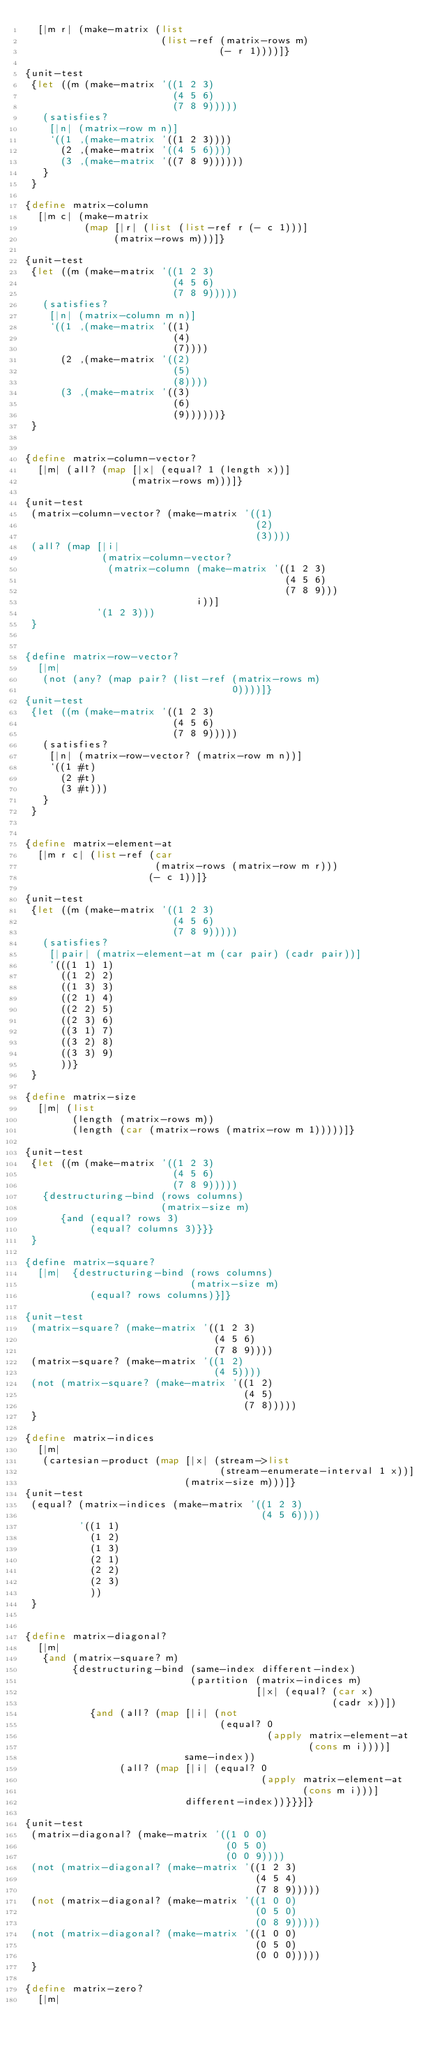Convert code to text. <code><loc_0><loc_0><loc_500><loc_500><_Scheme_>  [|m r| (make-matrix (list
                       (list-ref (matrix-rows m)
                                 (- r 1))))]}

{unit-test
 {let ((m (make-matrix '((1 2 3)
                         (4 5 6)
                         (7 8 9)))))
   (satisfies?
    [|n| (matrix-row m n)]
    `((1 ,(make-matrix '((1 2 3))))
      (2 ,(make-matrix '((4 5 6))))
      (3 ,(make-matrix '((7 8 9))))))
   }
 }

{define matrix-column
  [|m c| (make-matrix
          (map [|r| (list (list-ref r (- c 1)))]
               (matrix-rows m)))]}

{unit-test
 {let ((m (make-matrix '((1 2 3)
                         (4 5 6)
                         (7 8 9)))))
   (satisfies?
    [|n| (matrix-column m n)]
    `((1 ,(make-matrix '((1)
                         (4)
                         (7))))
      (2 ,(make-matrix '((2)
                         (5)
                         (8))))
      (3 ,(make-matrix '((3)
                         (6)
                         (9))))))}
 }


{define matrix-column-vector?
  [|m| (all? (map [|x| (equal? 1 (length x))]
                  (matrix-rows m)))]}

{unit-test
 (matrix-column-vector? (make-matrix '((1)
                                       (2)
                                       (3))))
 (all? (map [|i|
             (matrix-column-vector?
              (matrix-column (make-matrix '((1 2 3)
                                            (4 5 6)
                                            (7 8 9)))
                             i))]
            '(1 2 3)))
 }


{define matrix-row-vector?
  [|m|
   (not (any? (map pair? (list-ref (matrix-rows m)
                                   0))))]}
{unit-test
 {let ((m (make-matrix '((1 2 3)
                         (4 5 6)
                         (7 8 9)))))
   (satisfies?
    [|n| (matrix-row-vector? (matrix-row m n))]
    `((1 #t)
      (2 #t)
      (3 #t)))
   }
 }


{define matrix-element-at
  [|m r c| (list-ref (car
                      (matrix-rows (matrix-row m r)))
                     (- c 1))]}

{unit-test
 {let ((m (make-matrix '((1 2 3)
                         (4 5 6)
                         (7 8 9)))))
   (satisfies?
    [|pair| (matrix-element-at m (car pair) (cadr pair))]
    '(((1 1) 1)
      ((1 2) 2)
      ((1 3) 3)
      ((2 1) 4)
      ((2 2) 5)
      ((2 3) 6)
      ((3 1) 7)
      ((3 2) 8)
      ((3 3) 9)
      ))}
 }

{define matrix-size
  [|m| (list
        (length (matrix-rows m))
        (length (car (matrix-rows (matrix-row m 1)))))]}

{unit-test
 {let ((m (make-matrix '((1 2 3)
                         (4 5 6)
                         (7 8 9)))))
   {destructuring-bind (rows columns)
                       (matrix-size m)
      {and (equal? rows 3)
           (equal? columns 3)}}}
 }

{define matrix-square?
  [|m|  {destructuring-bind (rows columns)
                            (matrix-size m)
           (equal? rows columns)}]}

{unit-test
 (matrix-square? (make-matrix '((1 2 3)
                                (4 5 6)
                                (7 8 9))))
 (matrix-square? (make-matrix '((1 2)
                                (4 5))))
 (not (matrix-square? (make-matrix '((1 2)
                                     (4 5)
                                     (7 8)))))
 }

{define matrix-indices
  [|m|
   (cartesian-product (map [|x| (stream->list
                                 (stream-enumerate-interval 1 x))]
                           (matrix-size m)))]}
{unit-test
 (equal? (matrix-indices (make-matrix '((1 2 3)
                                        (4 5 6))))
         '((1 1)
           (1 2)
           (1 3)
           (2 1)
           (2 2)
           (2 3)
           ))
 }


{define matrix-diagonal?
  [|m|
   {and (matrix-square? m)
        {destructuring-bind (same-index different-index)
                            (partition (matrix-indices m)
                                       [|x| (equal? (car x)
                                                    (cadr x))])
           {and (all? (map [|i| (not
                                 (equal? 0
                                         (apply matrix-element-at
                                                (cons m i))))]
                           same-index))
                (all? (map [|i| (equal? 0
                                        (apply matrix-element-at
                                               (cons m i)))]
                           different-index))}}}]}

{unit-test
 (matrix-diagonal? (make-matrix '((1 0 0)
                                  (0 5 0)
                                  (0 0 9))))
 (not (matrix-diagonal? (make-matrix '((1 2 3)
                                       (4 5 4)
                                       (7 8 9)))))
 (not (matrix-diagonal? (make-matrix '((1 0 0)
                                       (0 5 0)
                                       (0 8 9)))))
 (not (matrix-diagonal? (make-matrix '((1 0 0)
                                       (0 5 0)
                                       (0 0 0)))))
 }

{define matrix-zero?
  [|m|</code> 